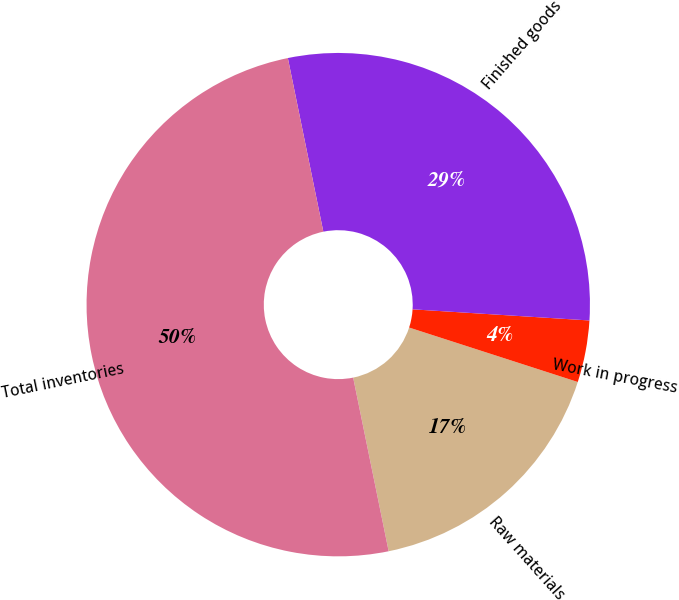<chart> <loc_0><loc_0><loc_500><loc_500><pie_chart><fcel>Raw materials<fcel>Work in progress<fcel>Finished goods<fcel>Total inventories<nl><fcel>16.82%<fcel>3.97%<fcel>29.21%<fcel>50.0%<nl></chart> 